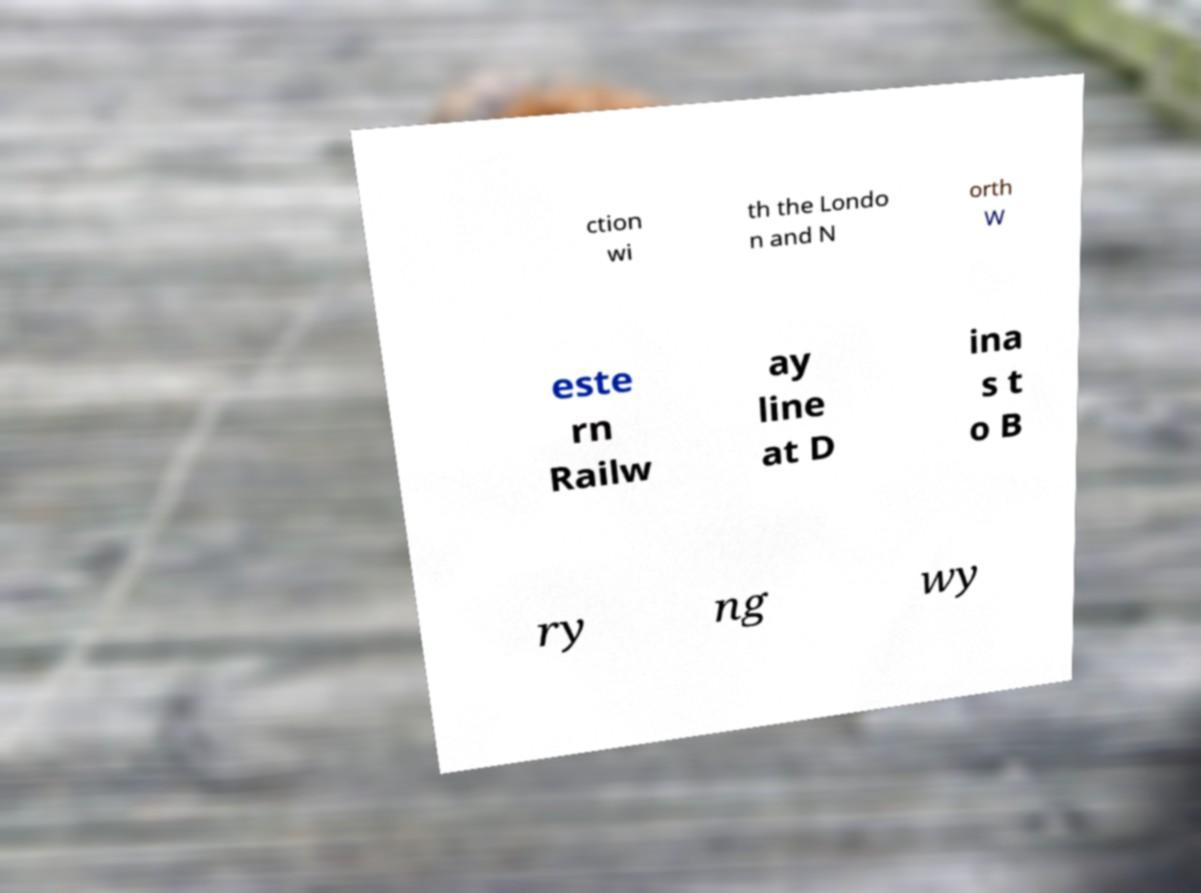Please identify and transcribe the text found in this image. ction wi th the Londo n and N orth W este rn Railw ay line at D ina s t o B ry ng wy 